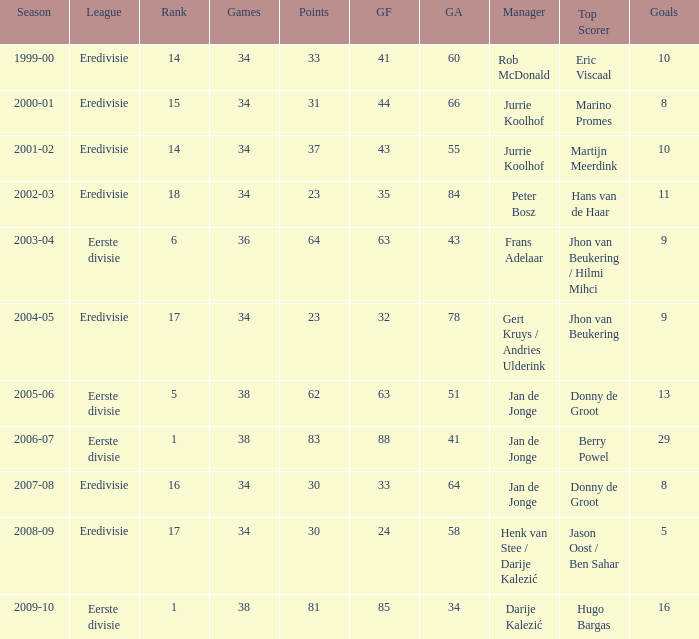Who is the leading scorer when the goal count is 41? Eric Viscaal. 